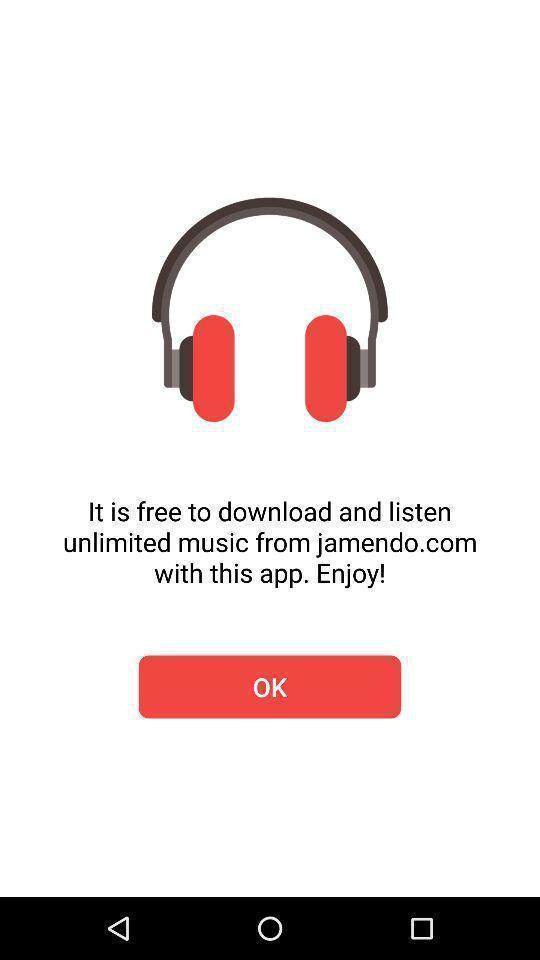Give me a narrative description of this picture. Welcome page of a music related app. 